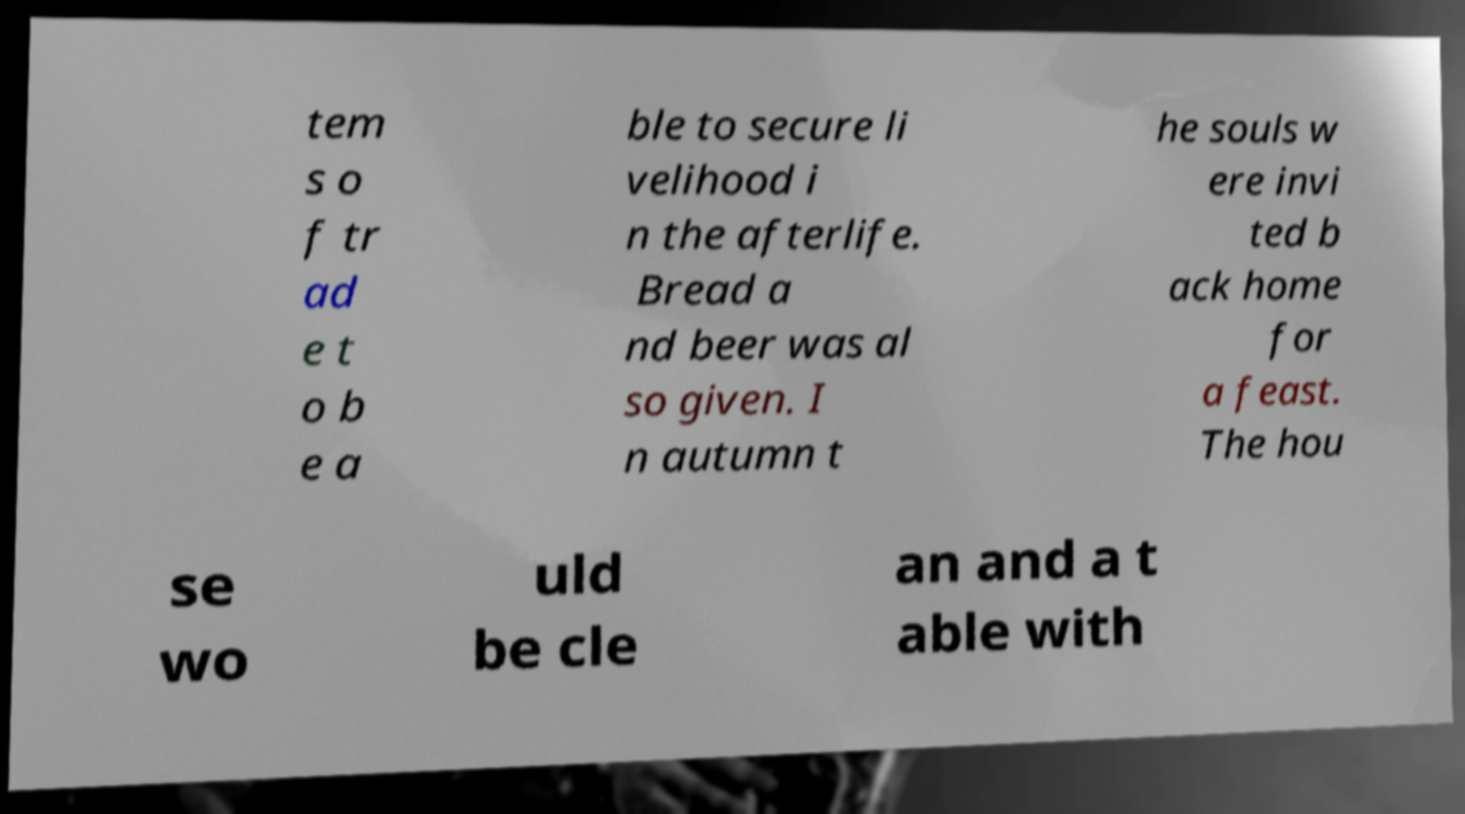There's text embedded in this image that I need extracted. Can you transcribe it verbatim? tem s o f tr ad e t o b e a ble to secure li velihood i n the afterlife. Bread a nd beer was al so given. I n autumn t he souls w ere invi ted b ack home for a feast. The hou se wo uld be cle an and a t able with 